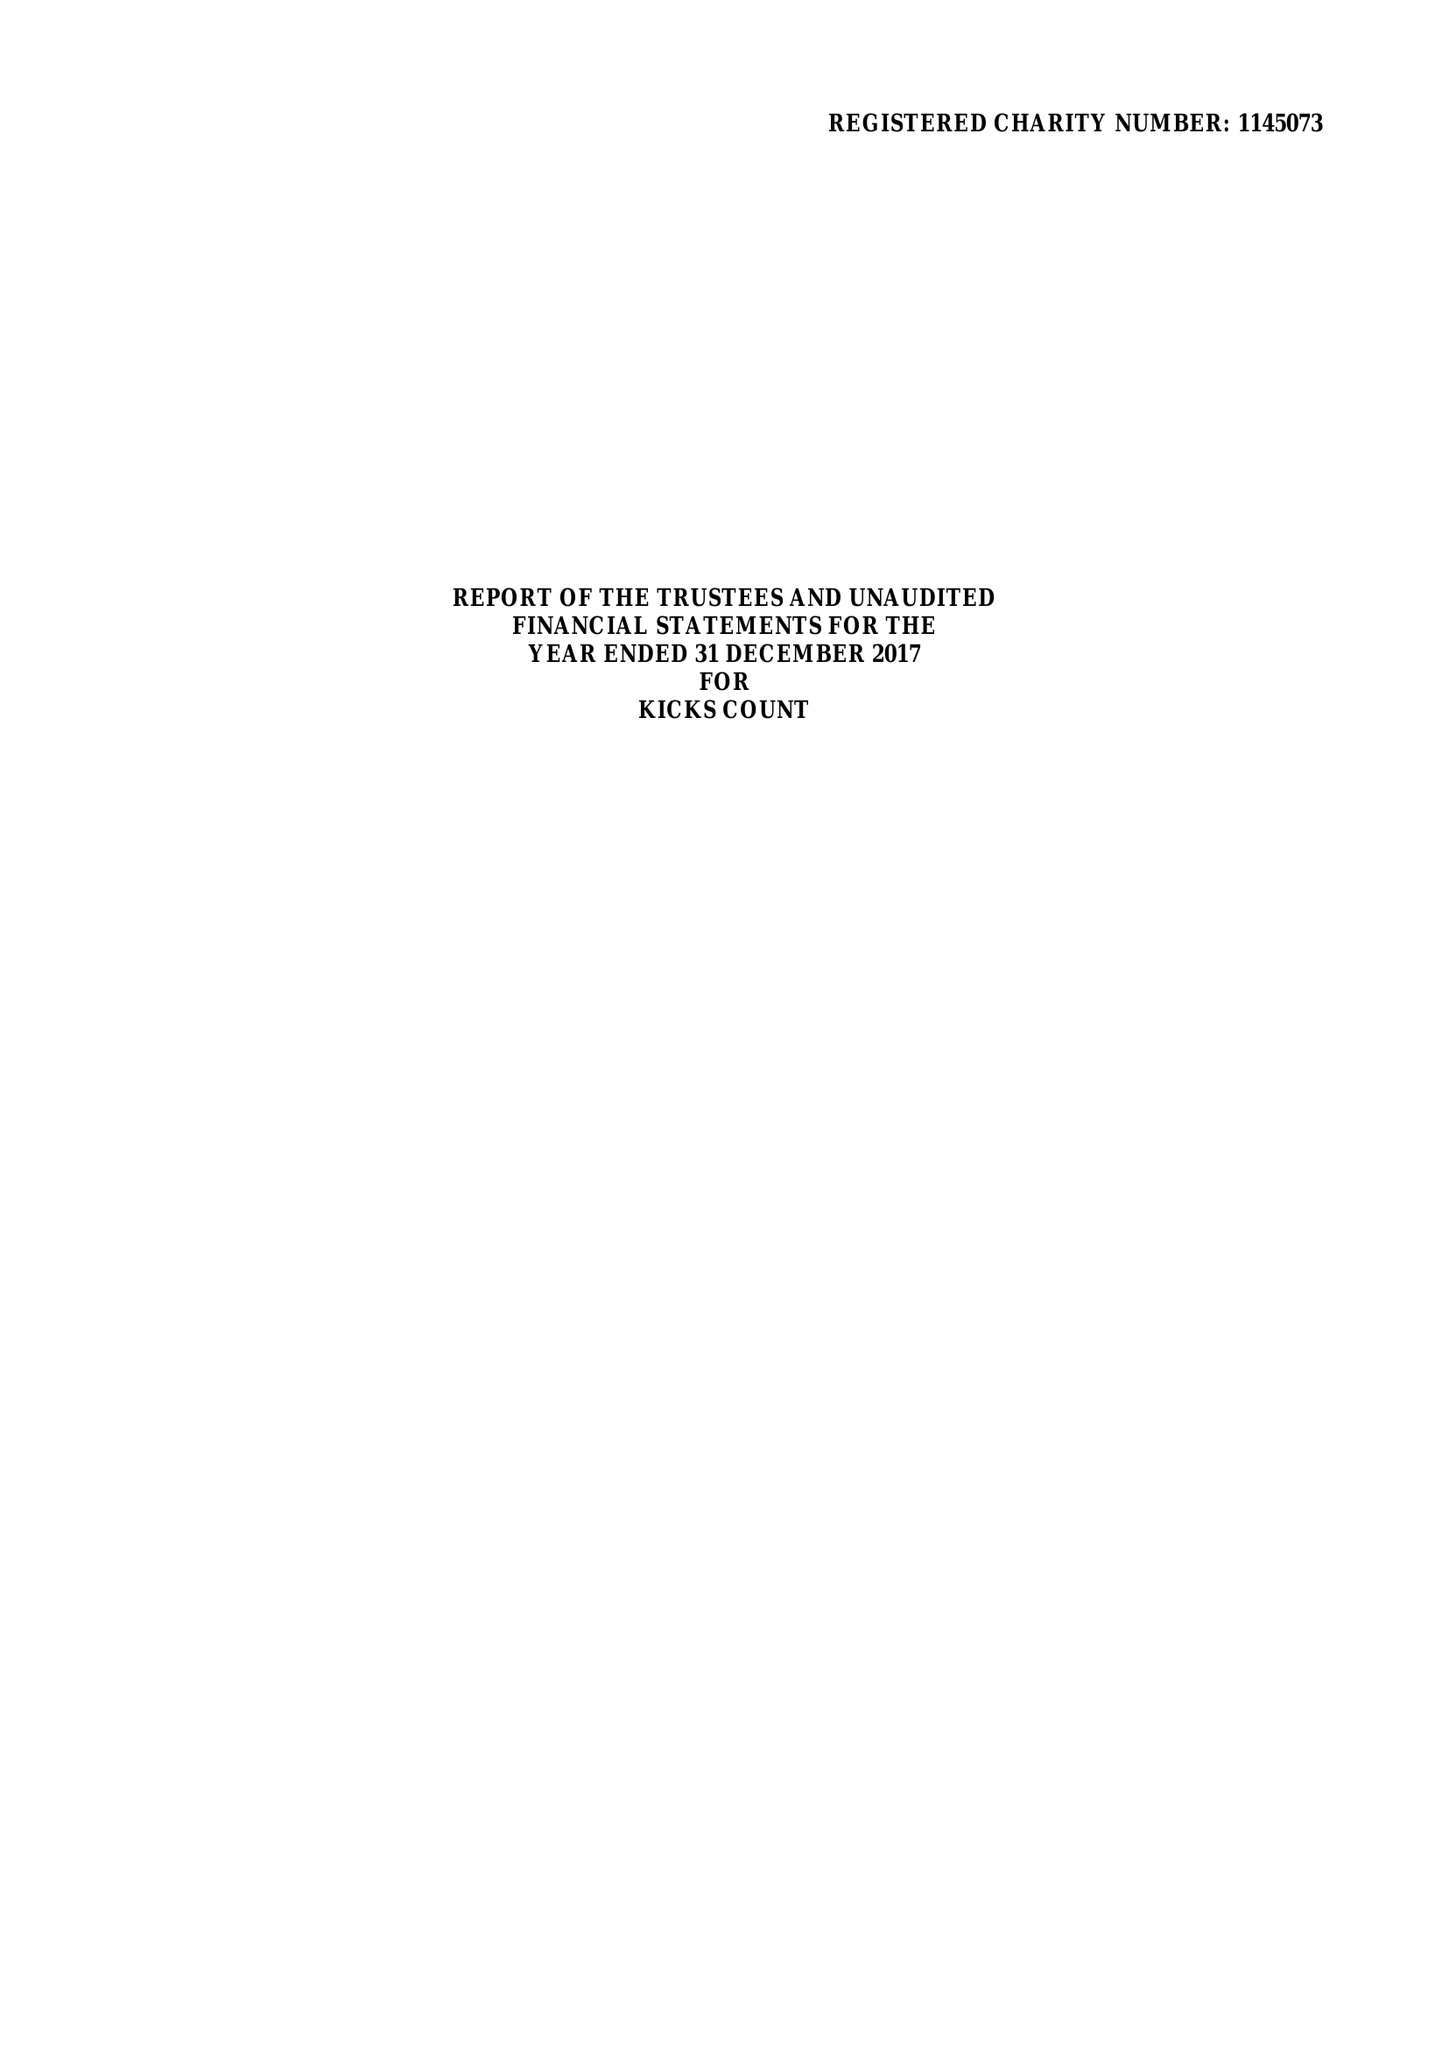What is the value for the charity_name?
Answer the question using a single word or phrase. Kicks Count 